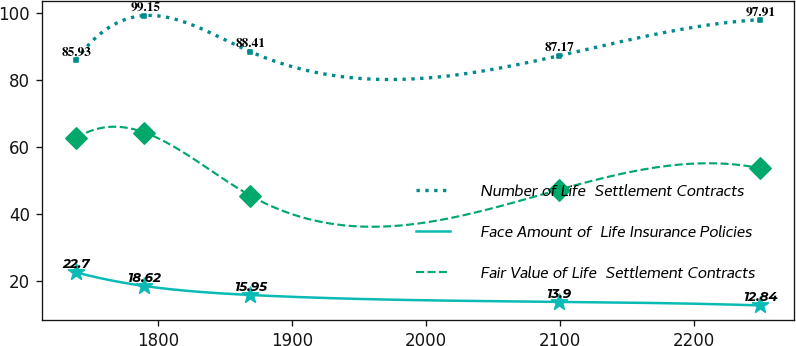Convert chart to OTSL. <chart><loc_0><loc_0><loc_500><loc_500><line_chart><ecel><fcel>Number of Life  Settlement Contracts<fcel>Face Amount of  Life Insurance Policies<fcel>Fair Value of Life  Settlement Contracts<nl><fcel>1738.5<fcel>85.93<fcel>22.7<fcel>62.62<nl><fcel>1789.62<fcel>99.15<fcel>18.62<fcel>64.33<nl><fcel>1868.66<fcel>88.41<fcel>15.95<fcel>45.55<nl><fcel>2099.21<fcel>87.17<fcel>13.9<fcel>47.26<nl><fcel>2249.68<fcel>97.91<fcel>12.84<fcel>53.7<nl></chart> 